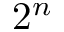Convert formula to latex. <formula><loc_0><loc_0><loc_500><loc_500>2 ^ { n }</formula> 